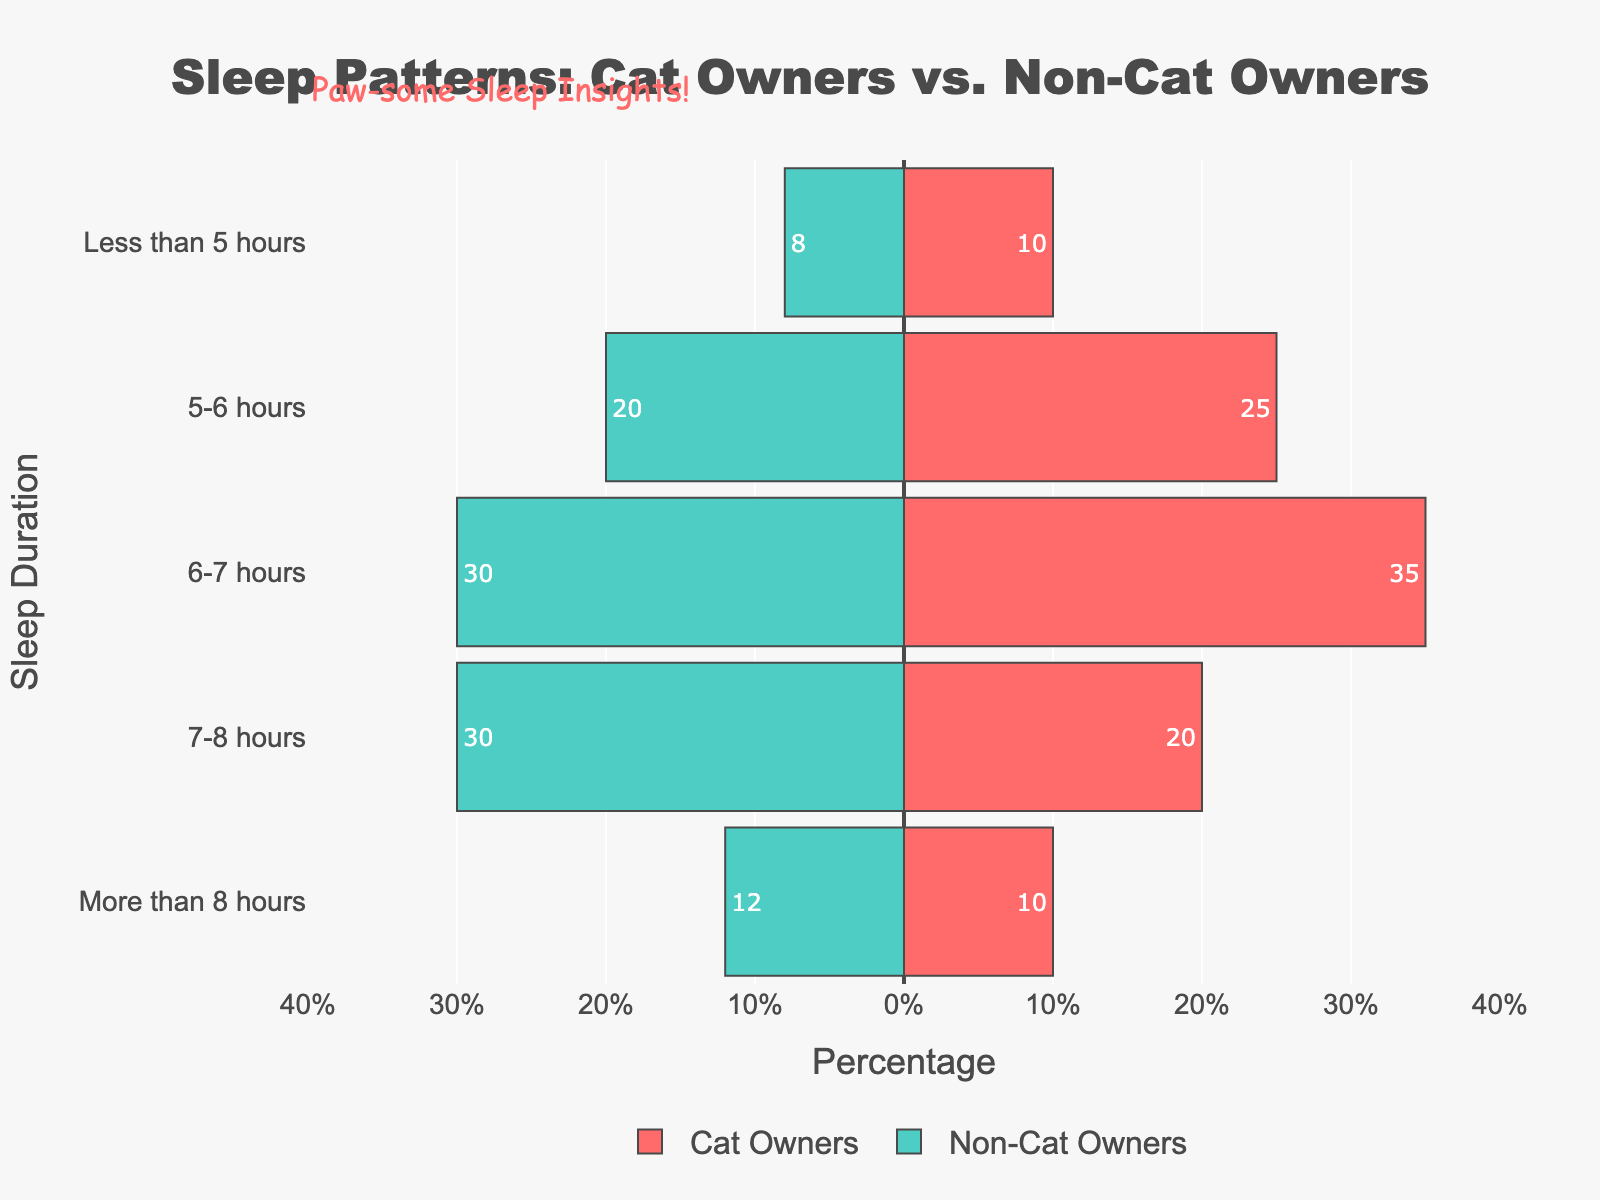Which group has a higher percentage of people getting 7-8 hours of sleep? To find this, we check the bar lengths for the "7-8 hours" category. Cat Owners have 20%, whereas Non-Cat Owners have 30%.
Answer: Non-Cat Owners What is the largest difference in percentage between Cat Owners and Non-Cat Owners for any sleep category? Identify the sleep category with the most considerable difference. The "7-8 hours" category shows a 10% difference (20% for Cat Owners and 30% for Non-Cat Owners).
Answer: 10% What is the total percentage of Cat Owners sleeping between 5-7 hours? Add the percentages of Cat Owners in the "5-6 hours" and "6-7 hours" categories: 25% + 35% = 60%.
Answer: 60% Are more Cat Owners or Non-Cat Owners getting less than 5 hours of sleep? Compare the percentages of Cat Owners and Non-Cat Owners in the "Less than 5 hours" category. Cat Owners have 10%, and Non-Cat Owners have 8%.
Answer: Cat Owners Which group has a higher percentage of people sleeping more than 8 hours? Compare the "More than 8 hours" percentages. Non-Cat Owners have 12%, while Cat Owners have 10%.
Answer: Non-Cat Owners What is the combined percentage of Non-Cat Owners that sleep less than 7 hours? Sum the percentages of Non-Cat Owners in the "Less than 5 hours," "5-6 hours," and "6-7 hours" categories (8% + 20% + 30% = 58%).
Answer: 58% For the "6-7 hours" category, by what percentage are Cat Owners higher than Non-Cat Owners? Subtract the percentage of Non-Cat Owners from Cat Owners in the "6-7 hours" category (35% - 30% = 5%).
Answer: 5% What proportion of Non-Cat Owners sleep at least 7 hours? Sum the percentages of Non-Cat Owners in the "7-8 hours" and "More than 8 hours" categories (30% + 12% = 42%).
Answer: 42% Between which two sleep categories is the percentage difference among Cat Owners most noticeable? Compare percentage differences for Cat Owners between consecutive categories. The largest difference is between "6-7 hours" (35%) and "7-8 hours" (20%), with a difference of 15%.
Answer: "6-7 hours" and "7-8 hours" 